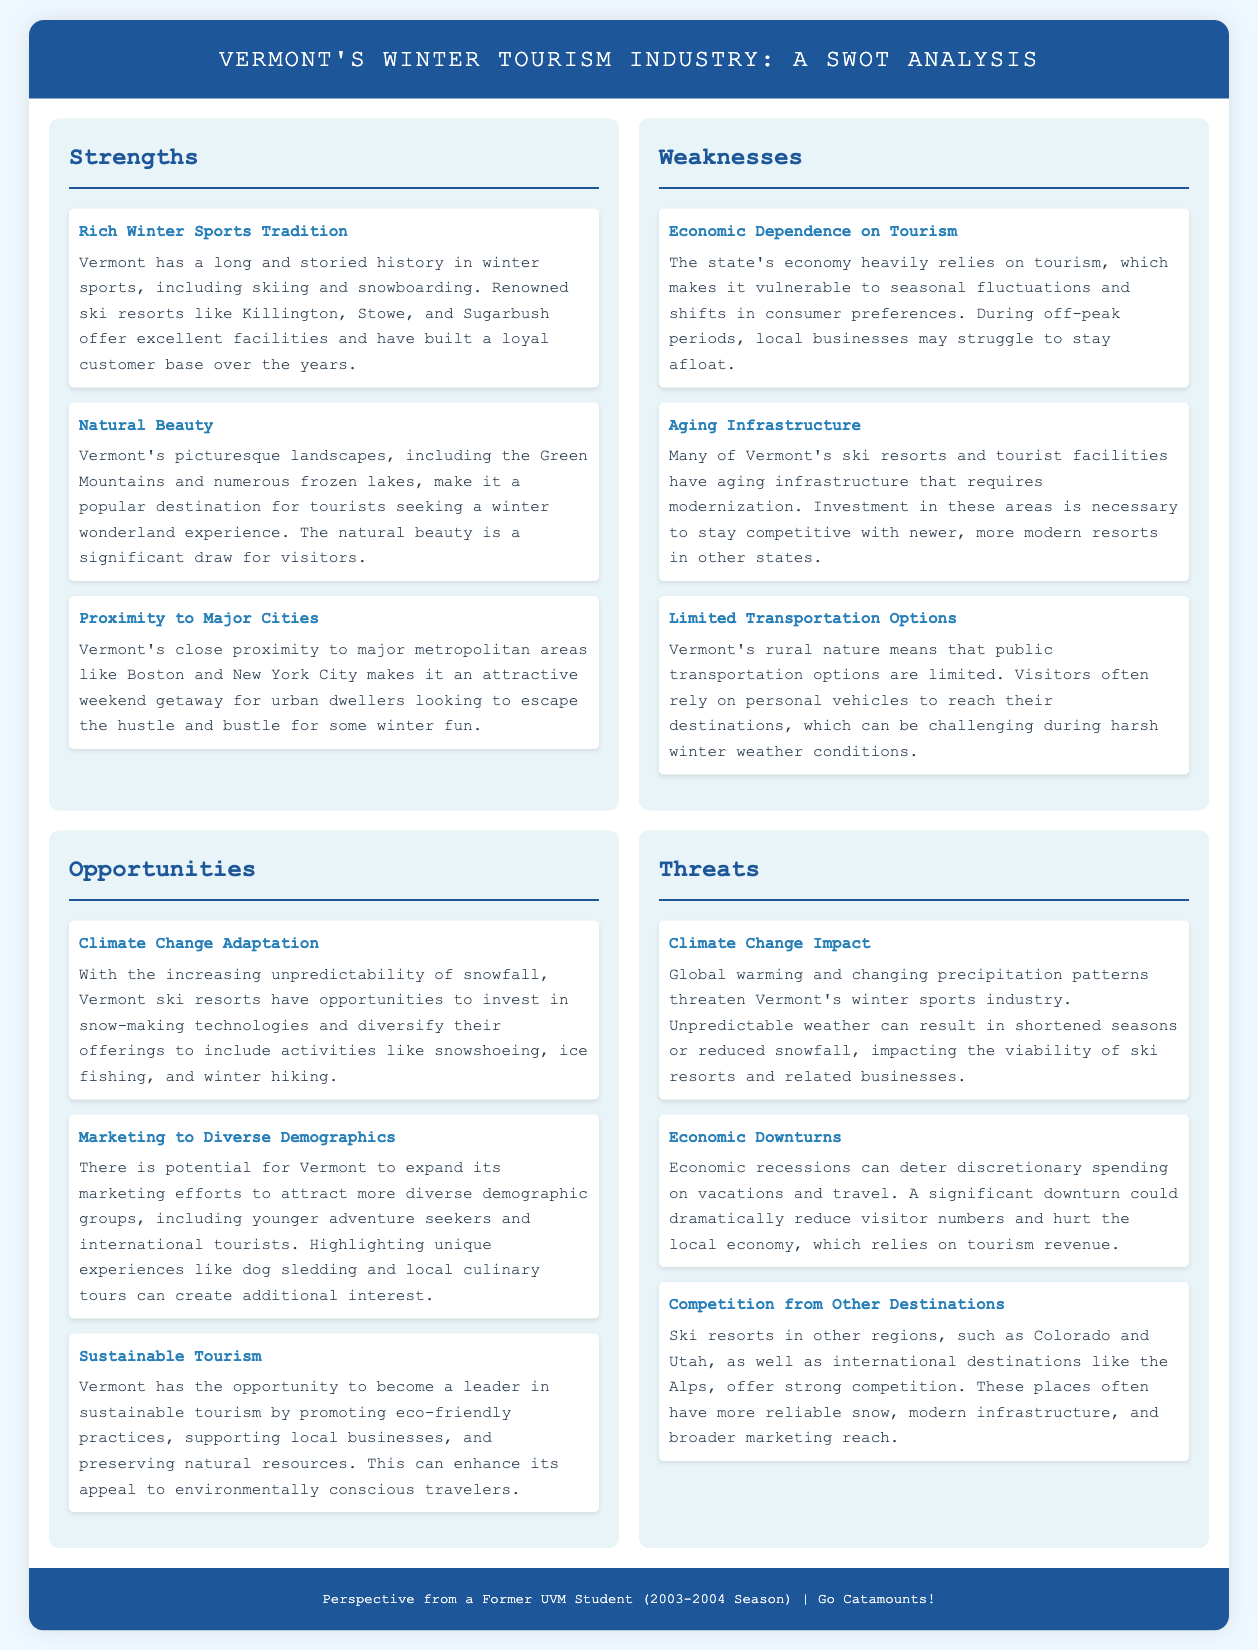what is a significant strength of Vermont's winter tourism industry? Vermont's winter tourism industry has a long and storied history in winter sports, including skiing and snowboarding.
Answer: Rich Winter Sports Tradition what opportunity is suggested for Vermont's ski resorts? The document suggests that Vermont ski resorts have opportunities to invest in snow-making technologies.
Answer: Climate Change Adaptation what is a key threat to Vermont's winter tourism industry? The threat posed by global warming and changing precipitation patterns is highlighted in the document.
Answer: Climate Change Impact which demographic does Vermont aim to attract with its marketing efforts? The document mentions that Vermont can expand its marketing efforts to attract more diverse demographic groups, including younger adventure seekers.
Answer: Diverse Demographics how does aging infrastructure impact Vermont's tourism? The infrastructure's age means it requires modernization to remain competitive with newer resorts.
Answer: Requires modernization what is a specific competition threat mentioned in the analysis? The document highlights competition from ski resorts in other regions, specifically mentioning Colorado and Utah.
Answer: Competition from Other Destinations how can Vermont position itself in the tourism market? By promoting eco-friendly practices and supporting local businesses, Vermont can enhance its tourism appeal.
Answer: Sustainable Tourism what geographical location is Vermont close to that enhances its tourism? Vermont's proximity to major metropolitan areas like Boston and New York City is mentioned as a factor that enhances its tourism appeal.
Answer: Major Cities 